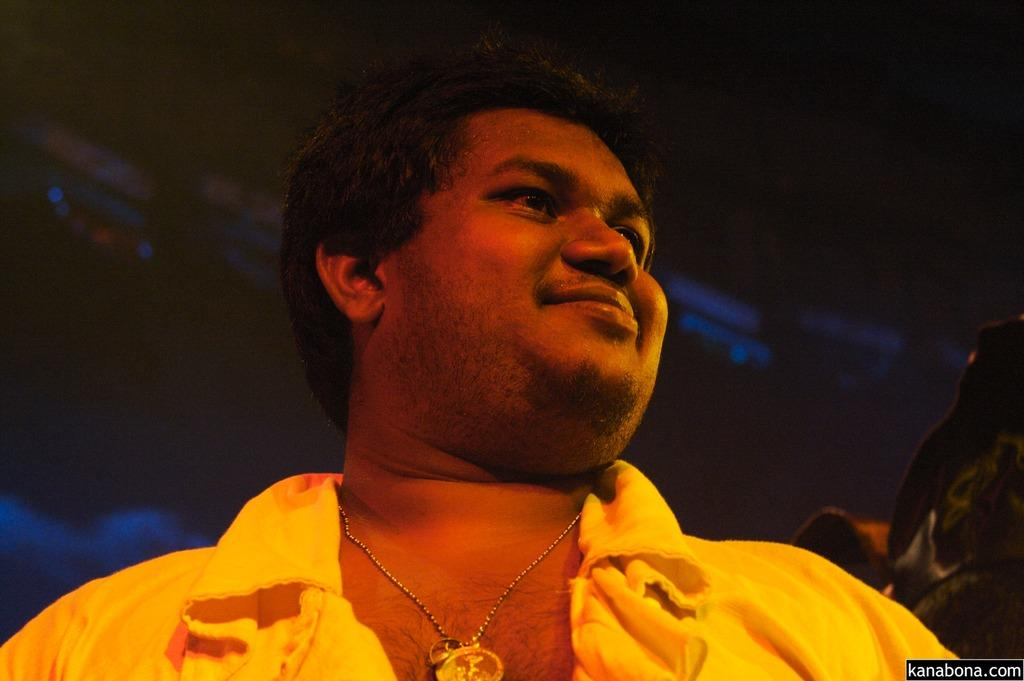Who is present in the image? There is a man in the picture. What is the man doing in the image? The man is looking to the side and smiling. What is the man wearing in the image? The man is wearing a yellow shirt. Can you describe any accessories the man is wearing in the image? The man has a chain with a locket around his neck. What can be observed about the background of the image? The background of the image appears to be dark. What type of tail does the man have in the image? There is no tail present on the man in the image. What color is the donkey's fur in the image? There is no donkey present in the image. 